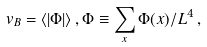Convert formula to latex. <formula><loc_0><loc_0><loc_500><loc_500>v _ { B } = \langle | \Phi | \rangle \, , \Phi \equiv \sum _ { x } \Phi ( x ) / L ^ { 4 } \, ,</formula> 